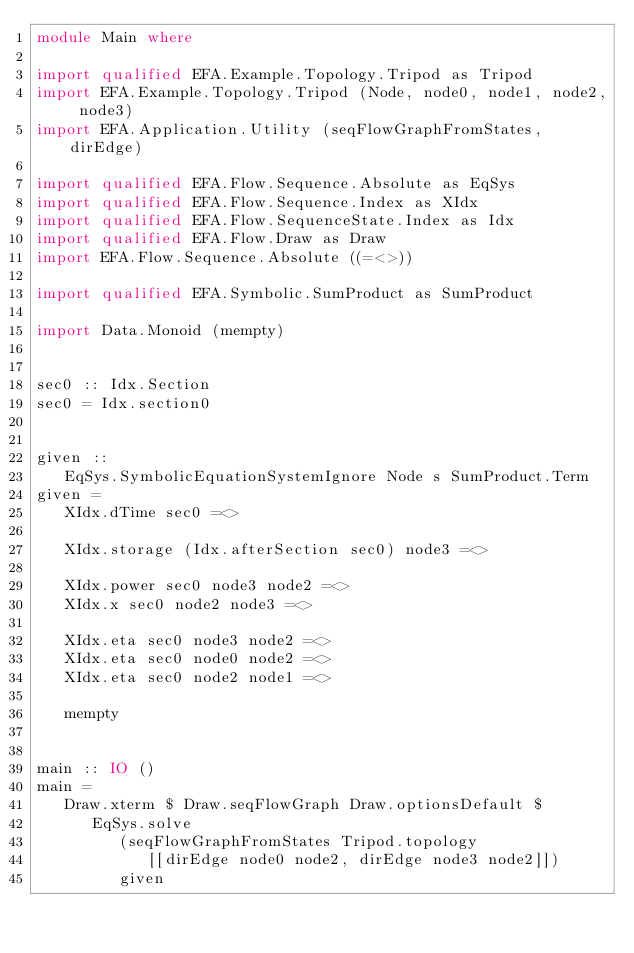Convert code to text. <code><loc_0><loc_0><loc_500><loc_500><_Haskell_>module Main where

import qualified EFA.Example.Topology.Tripod as Tripod
import EFA.Example.Topology.Tripod (Node, node0, node1, node2, node3)
import EFA.Application.Utility (seqFlowGraphFromStates, dirEdge)

import qualified EFA.Flow.Sequence.Absolute as EqSys
import qualified EFA.Flow.Sequence.Index as XIdx
import qualified EFA.Flow.SequenceState.Index as Idx
import qualified EFA.Flow.Draw as Draw
import EFA.Flow.Sequence.Absolute ((=<>))

import qualified EFA.Symbolic.SumProduct as SumProduct

import Data.Monoid (mempty)


sec0 :: Idx.Section
sec0 = Idx.section0


given ::
   EqSys.SymbolicEquationSystemIgnore Node s SumProduct.Term
given =
   XIdx.dTime sec0 =<>

   XIdx.storage (Idx.afterSection sec0) node3 =<>

   XIdx.power sec0 node3 node2 =<>
   XIdx.x sec0 node2 node3 =<>

   XIdx.eta sec0 node3 node2 =<>
   XIdx.eta sec0 node0 node2 =<>
   XIdx.eta sec0 node2 node1 =<>

   mempty


main :: IO ()
main =
   Draw.xterm $ Draw.seqFlowGraph Draw.optionsDefault $
      EqSys.solve
         (seqFlowGraphFromStates Tripod.topology
            [[dirEdge node0 node2, dirEdge node3 node2]])
         given
</code> 